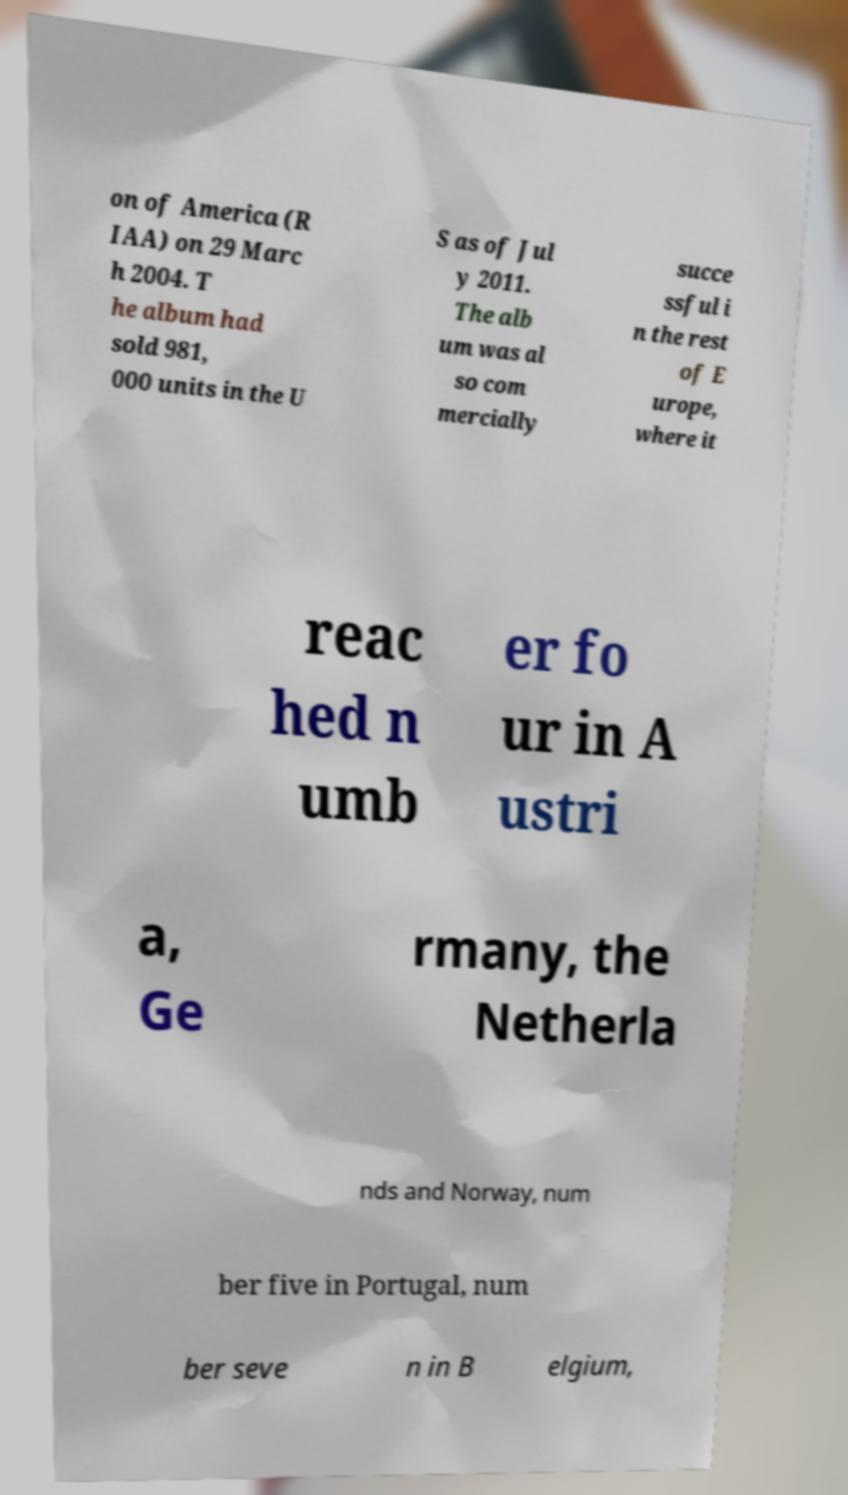Please read and relay the text visible in this image. What does it say? on of America (R IAA) on 29 Marc h 2004. T he album had sold 981, 000 units in the U S as of Jul y 2011. The alb um was al so com mercially succe ssful i n the rest of E urope, where it reac hed n umb er fo ur in A ustri a, Ge rmany, the Netherla nds and Norway, num ber five in Portugal, num ber seve n in B elgium, 